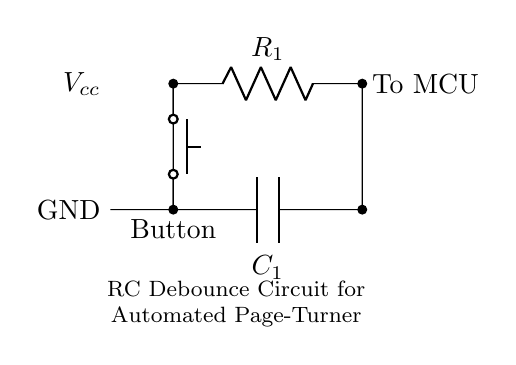What is the type of circuit shown? The circuit is a resistor-capacitor debounce circuit, which is specifically designed to prevent false triggering from the mechanical bounce of a push button.
Answer: Resistor-capacitor debounce circuit What component connects to the microcontroller? The resistor connects to the microcontroller, which processes the signal generated when the button is pressed.
Answer: Resistor What is the function of the capacitor in this circuit? The capacitor smooths out the voltage changes caused by the button press, effectively filtering out noise and mechanical bounce to create a stable signal for the microcontroller.
Answer: Filtering What is the role of the push button? The push button acts as a switch that initiates the signal, which is processed through the RC arrangement to debounce the output.
Answer: Initiate signal How does the RC time constant affect button debouncing? The RC time constant determines how quickly the capacitor charges and discharges, affecting the duration of the output high or low state after a button press. A higher time constant results in slower response and improved debouncing.
Answer: Duration of signal What are the potential voltage levels present in this circuit? The voltage levels would typically be from ground (zero volts) to the supply voltage, which is marked as Vcc, representing the maximum voltage provided to the circuit, commonly five volts.
Answer: Zero to five volts What is the best value for the resistor to achieve effective debouncing? The best resistor value depends on the specific capacitance used; common values for the resistor might be in the range of one kilo-ohm to ten kilo-ohms, allowing a suitable RC time constant with the chosen capacitor.
Answer: One to ten kilo-ohms 